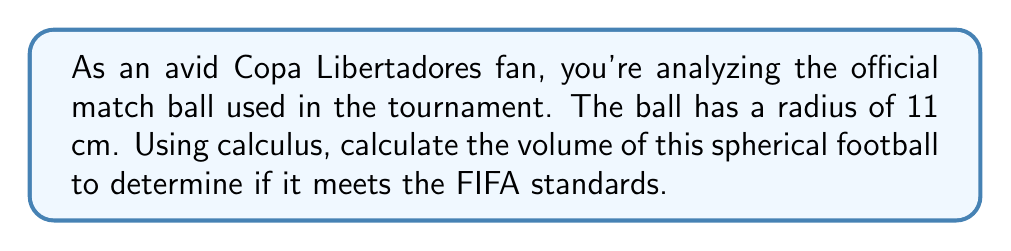Show me your answer to this math problem. To find the volume of a sphere using calculus, we'll use the method of shells:

1) First, we set up the integral. The volume of a spherical shell is given by:
   $$dV = 4\pi x^2 dx$$
   where $x$ is the radius of the shell.

2) We integrate this from 0 to the radius of the sphere (11 cm):
   $$V = \int_0^{11} 4\pi x^2 dx$$

3) Evaluate the integral:
   $$V = 4\pi \int_0^{11} x^2 dx = 4\pi \left[\frac{x^3}{3}\right]_0^{11}$$

4) Substitute the limits:
   $$V = 4\pi \left(\frac{11^3}{3} - \frac{0^3}{3}\right) = \frac{4\pi}{3}(11^3)$$

5) Calculate the final result:
   $$V = \frac{4\pi}{3}(1331) \approx 5575.28 \text{ cm}^3$$

[asy]
import geometry;

draw(circle((0,0),11), blue);
draw((-11,0)--(11,0), dashed);
draw((0,-11)--(0,11), dashed);
label("11 cm", (5.5,0), S);
[/asy]
Answer: $\frac{4\pi}{3}(11^3) \approx 5575.28 \text{ cm}^3$ 